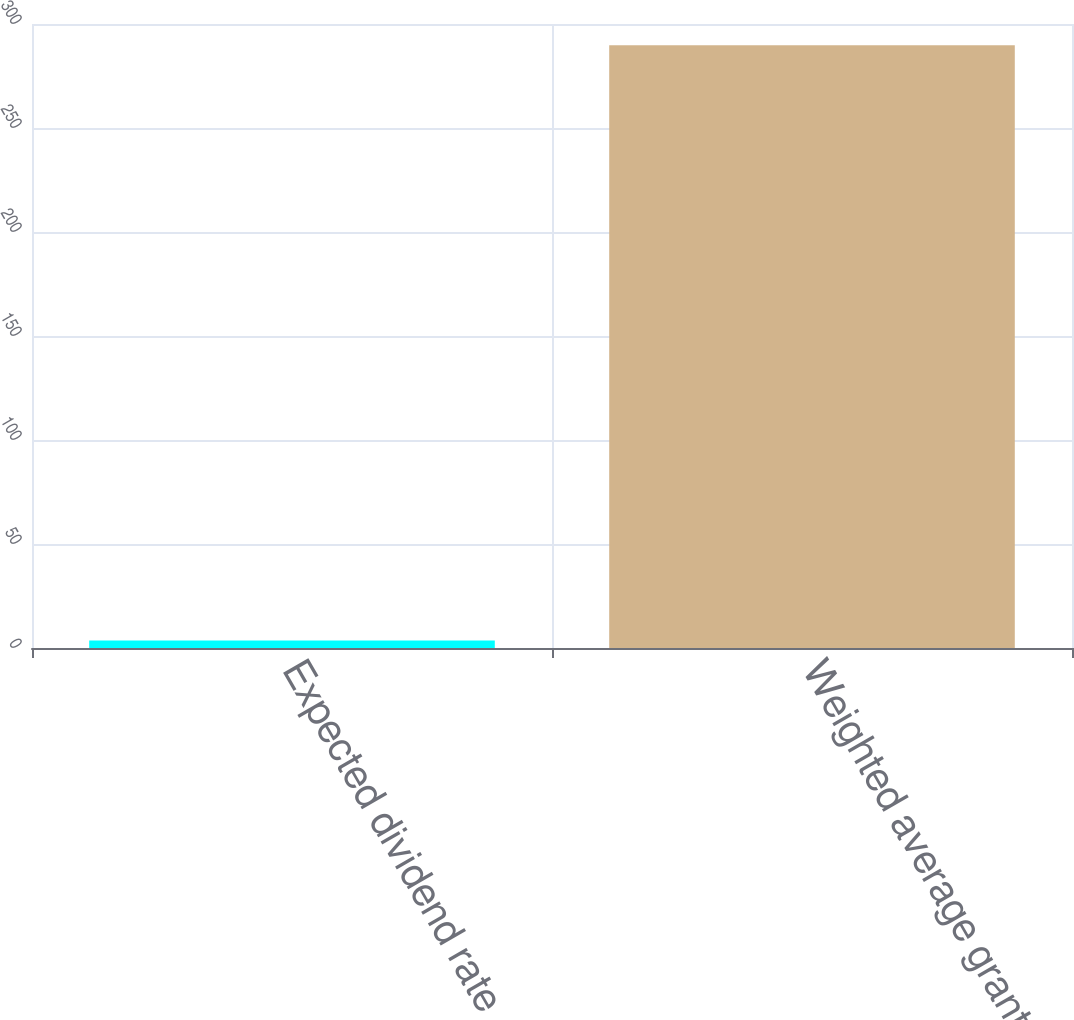Convert chart. <chart><loc_0><loc_0><loc_500><loc_500><bar_chart><fcel>Expected dividend rate<fcel>Weighted average grant-date<nl><fcel>3.57<fcel>289.81<nl></chart> 